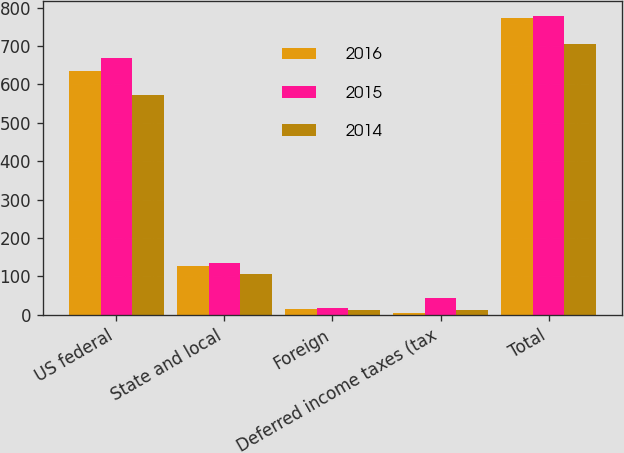Convert chart. <chart><loc_0><loc_0><loc_500><loc_500><stacked_bar_chart><ecel><fcel>US federal<fcel>State and local<fcel>Foreign<fcel>Deferred income taxes (tax<fcel>Total<nl><fcel>2016<fcel>635.8<fcel>126.8<fcel>16.3<fcel>5.4<fcel>773.5<nl><fcel>2015<fcel>669.5<fcel>134.3<fcel>18.9<fcel>43.3<fcel>779.4<nl><fcel>2014<fcel>573.7<fcel>105.8<fcel>13.5<fcel>13.5<fcel>706.5<nl></chart> 